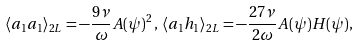Convert formula to latex. <formula><loc_0><loc_0><loc_500><loc_500>\langle a _ { 1 } a _ { 1 } \rangle _ { 2 L } = - \frac { 9 \nu } { \omega } A ( { \psi } ) ^ { 2 } \, , \, \langle a _ { 1 } h _ { 1 } \rangle _ { 2 L } = - \frac { 2 7 \nu } { 2 \omega } A ( { \psi } ) H ( { \psi } ) ,</formula> 